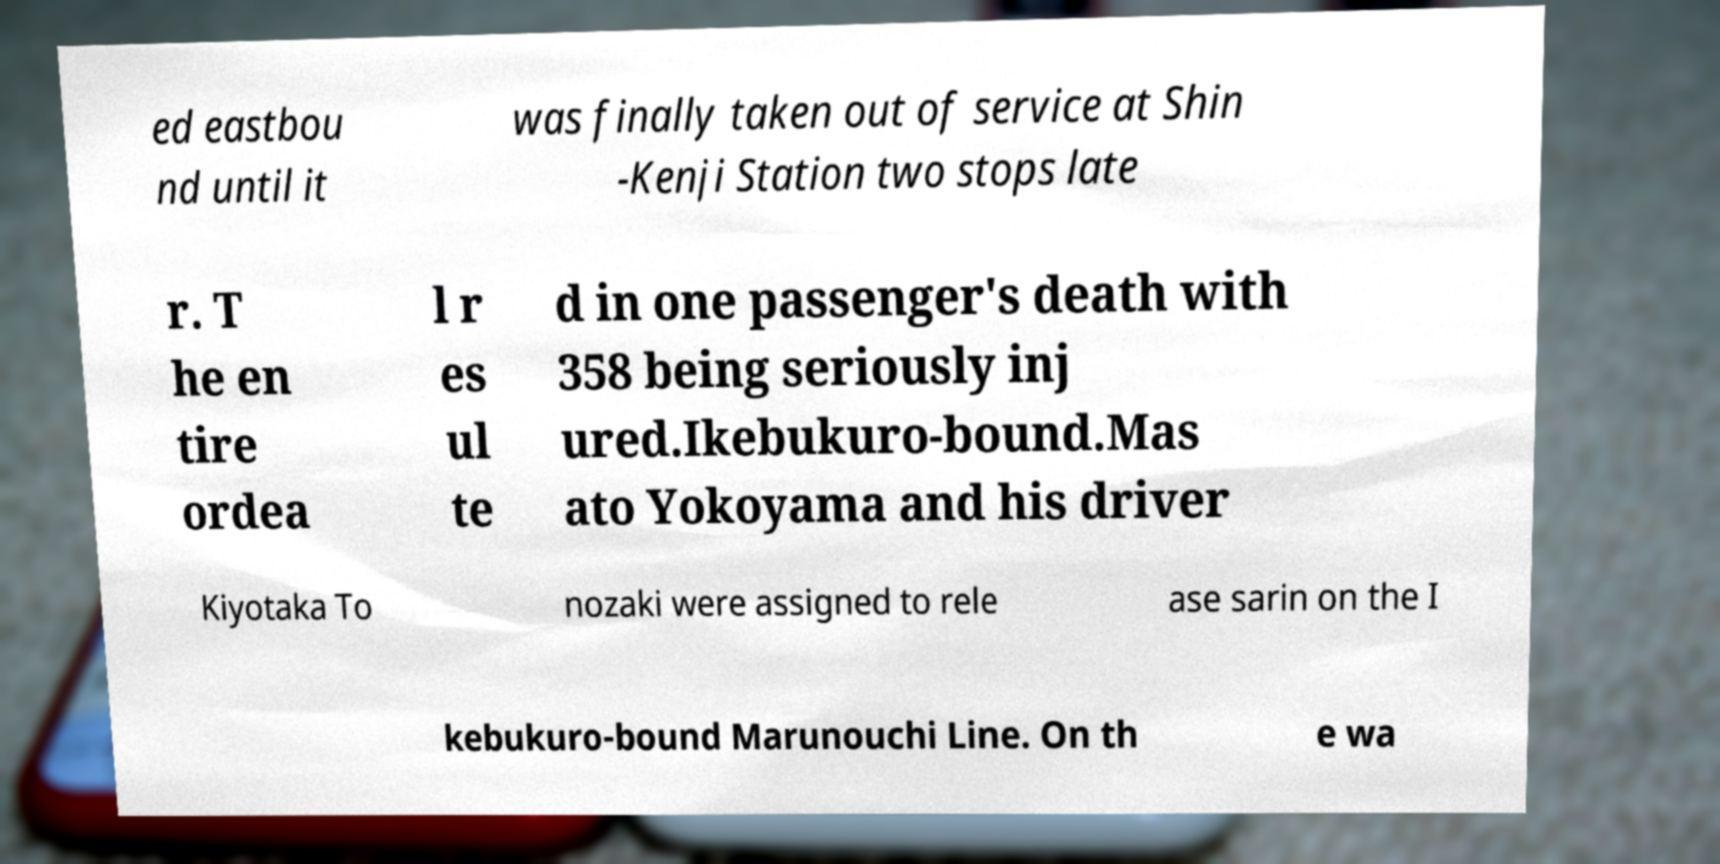Can you read and provide the text displayed in the image?This photo seems to have some interesting text. Can you extract and type it out for me? ed eastbou nd until it was finally taken out of service at Shin -Kenji Station two stops late r. T he en tire ordea l r es ul te d in one passenger's death with 358 being seriously inj ured.Ikebukuro-bound.Mas ato Yokoyama and his driver Kiyotaka To nozaki were assigned to rele ase sarin on the I kebukuro-bound Marunouchi Line. On th e wa 